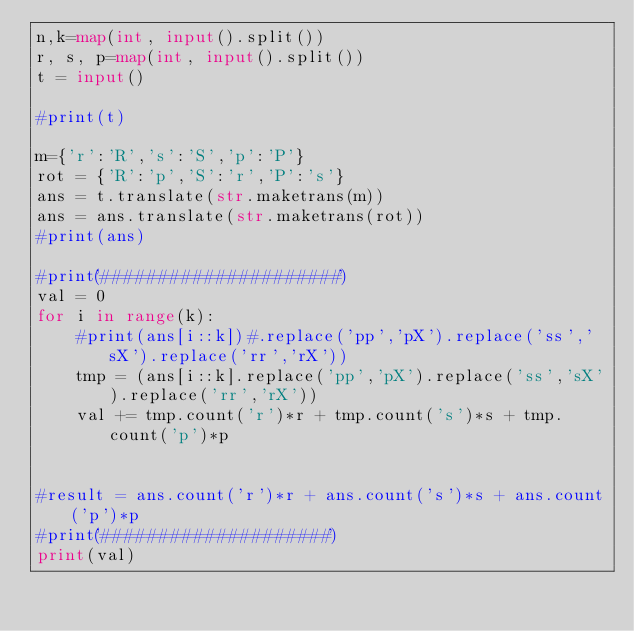Convert code to text. <code><loc_0><loc_0><loc_500><loc_500><_Python_>n,k=map(int, input().split())
r, s, p=map(int, input().split())
t = input()

#print(t)

m={'r':'R','s':'S','p':'P'}
rot = {'R':'p','S':'r','P':'s'}
ans = t.translate(str.maketrans(m))
ans = ans.translate(str.maketrans(rot))
#print(ans)

#print('#####################')
val = 0
for i in range(k):
    #print(ans[i::k])#.replace('pp','pX').replace('ss','sX').replace('rr','rX'))
    tmp = (ans[i::k].replace('pp','pX').replace('ss','sX').replace('rr','rX'))
    val += tmp.count('r')*r + tmp.count('s')*s + tmp.count('p')*p


#result = ans.count('r')*r + ans.count('s')*s + ans.count('p')*p
#print('####################')
print(val)</code> 